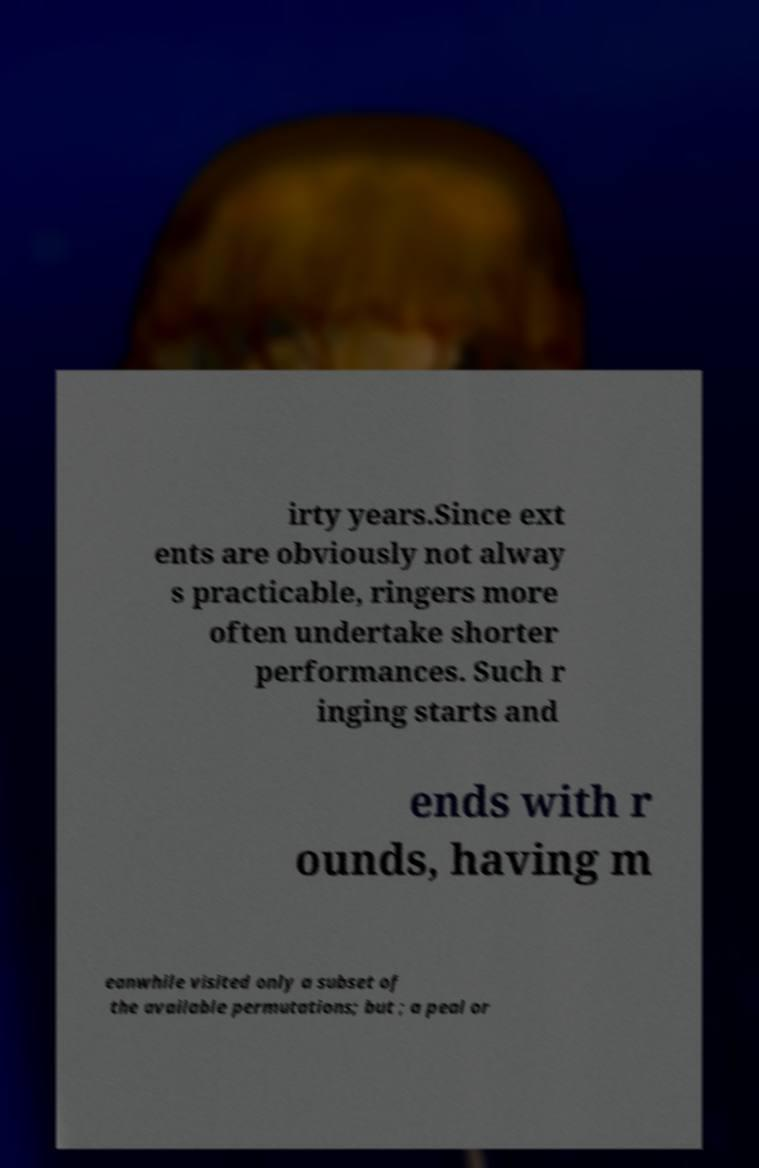Could you assist in decoding the text presented in this image and type it out clearly? irty years.Since ext ents are obviously not alway s practicable, ringers more often undertake shorter performances. Such r inging starts and ends with r ounds, having m eanwhile visited only a subset of the available permutations; but ; a peal or 